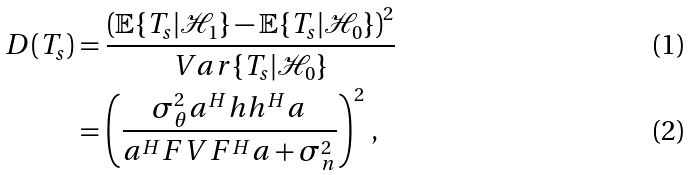Convert formula to latex. <formula><loc_0><loc_0><loc_500><loc_500>D ( T _ { s } ) & = \frac { \left ( \mathbb { E } \{ T _ { s } | \mathcal { H } _ { 1 } \} - \mathbb { E } \{ T _ { s } | \mathcal { H } _ { 0 } \} \right ) ^ { 2 } } { V a r \{ T _ { s } | \mathcal { H } _ { 0 } \} } \\ & = \left ( \frac { \sigma _ { \theta } ^ { 2 } a ^ { H } h h ^ { H } a } { a ^ { H } F V F ^ { H } a + \sigma ^ { 2 } _ { n } } \right ) ^ { 2 } \, ,</formula> 